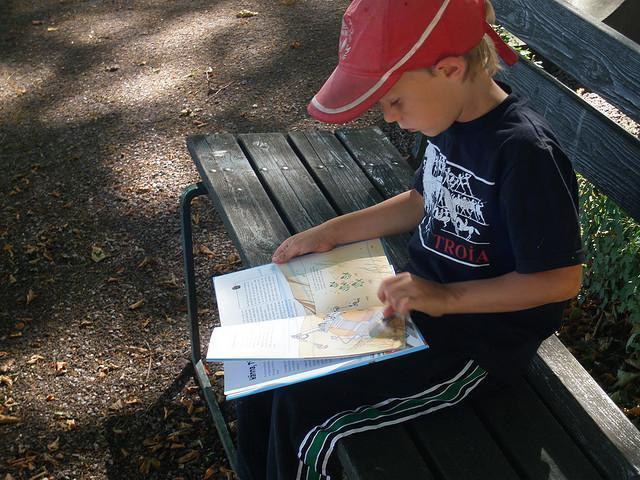How many slats are on the bench?
Give a very brief answer. 4. How many benches are visible?
Give a very brief answer. 1. How many books can you see?
Give a very brief answer. 1. How many of the people sitting have a laptop on there lap?
Give a very brief answer. 0. 